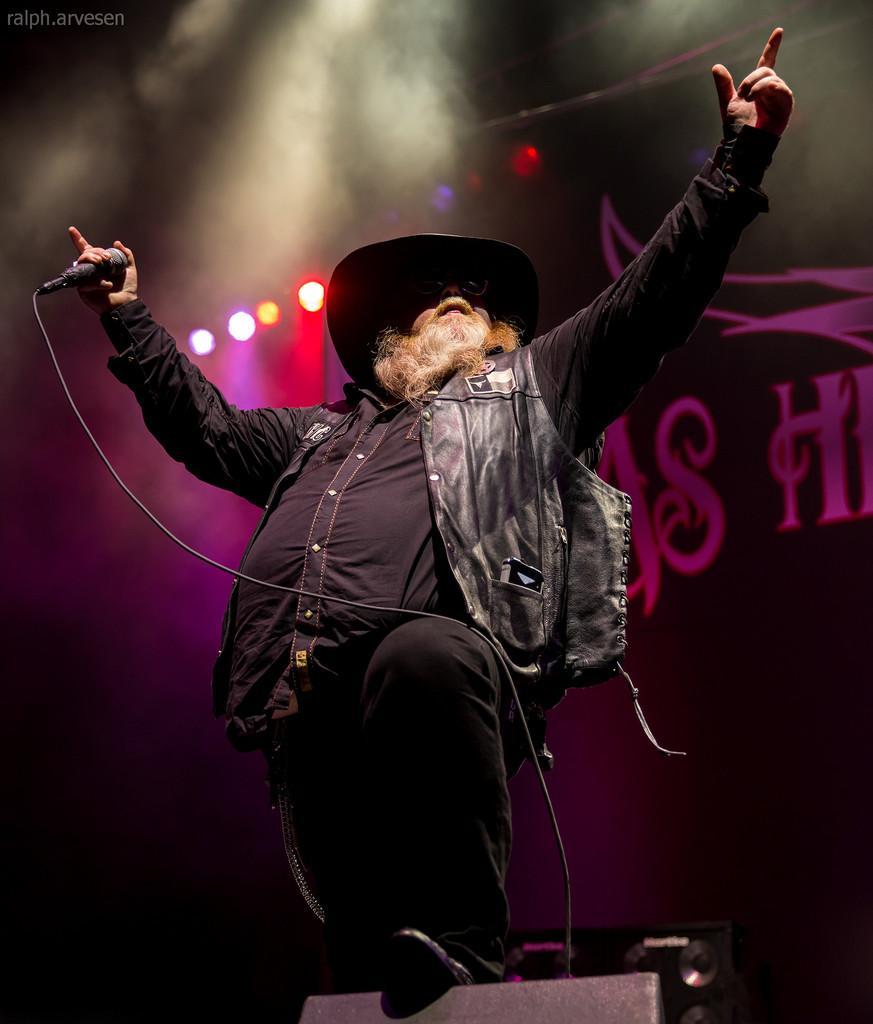How would you summarize this image in a sentence or two? In this picture we can see a person,he is holding a mic and in the background we can see lights. 